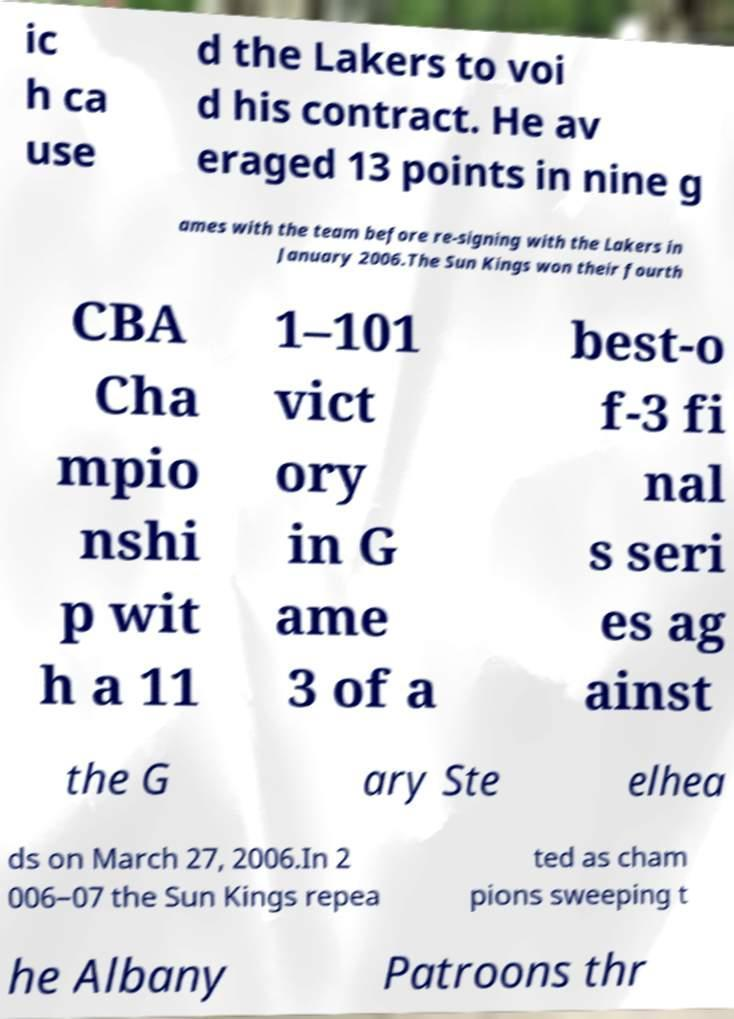Can you read and provide the text displayed in the image?This photo seems to have some interesting text. Can you extract and type it out for me? ic h ca use d the Lakers to voi d his contract. He av eraged 13 points in nine g ames with the team before re-signing with the Lakers in January 2006.The Sun Kings won their fourth CBA Cha mpio nshi p wit h a 11 1–101 vict ory in G ame 3 of a best-o f-3 fi nal s seri es ag ainst the G ary Ste elhea ds on March 27, 2006.In 2 006–07 the Sun Kings repea ted as cham pions sweeping t he Albany Patroons thr 